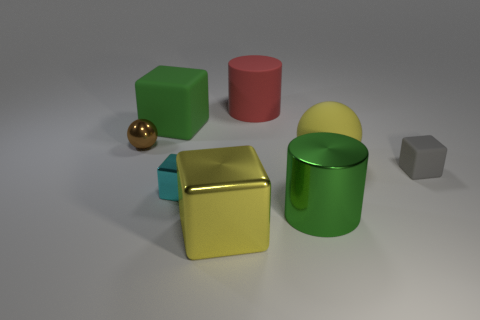Subtract all gray blocks. How many blocks are left? 3 Add 2 red things. How many objects exist? 10 Subtract all red cylinders. How many cylinders are left? 1 Subtract 2 cubes. How many cubes are left? 2 Add 2 small cyan metal cubes. How many small cyan metal cubes are left? 3 Add 1 shiny cylinders. How many shiny cylinders exist? 2 Subtract 0 cyan cylinders. How many objects are left? 8 Subtract all cyan blocks. Subtract all red balls. How many blocks are left? 3 Subtract all green metal cylinders. Subtract all small gray rubber things. How many objects are left? 6 